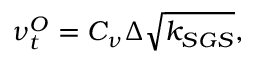Convert formula to latex. <formula><loc_0><loc_0><loc_500><loc_500>\nu _ { t } ^ { O } = C _ { \nu } \Delta \sqrt { k _ { S G S } } ,</formula> 